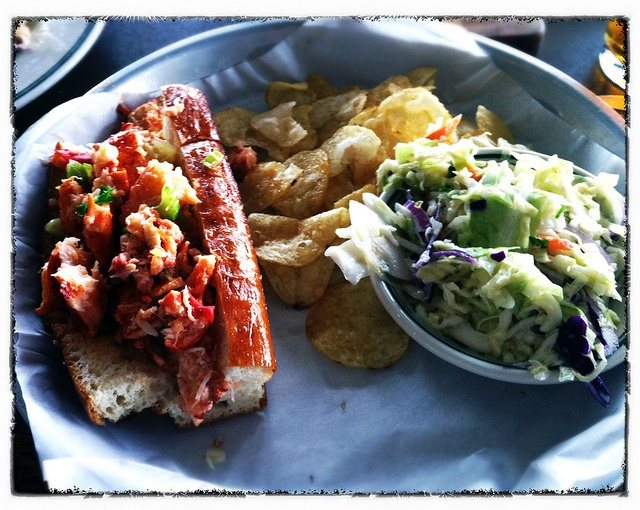Describe the objects in this image and their specific colors. I can see sandwich in white, black, maroon, and brown tones, bowl in white, black, ivory, gray, and darkgreen tones, and cup in white, blue, and gray tones in this image. 